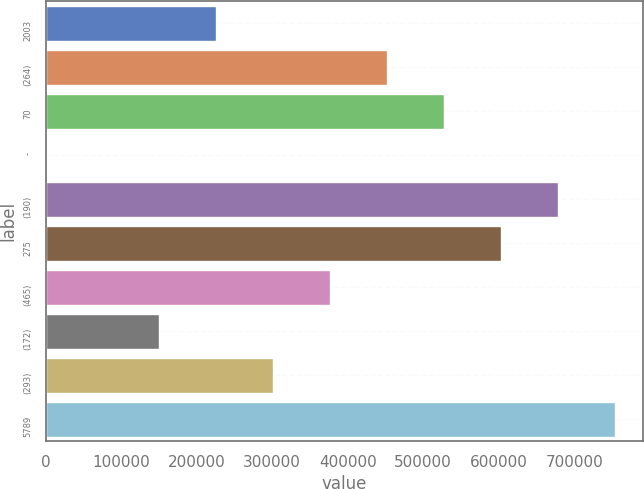<chart> <loc_0><loc_0><loc_500><loc_500><bar_chart><fcel>2003<fcel>(264)<fcel>70<fcel>-<fcel>(190)<fcel>275<fcel>(465)<fcel>(172)<fcel>(293)<fcel>5789<nl><fcel>226209<fcel>452383<fcel>527774<fcel>35<fcel>678557<fcel>603165<fcel>376992<fcel>150818<fcel>301600<fcel>753948<nl></chart> 